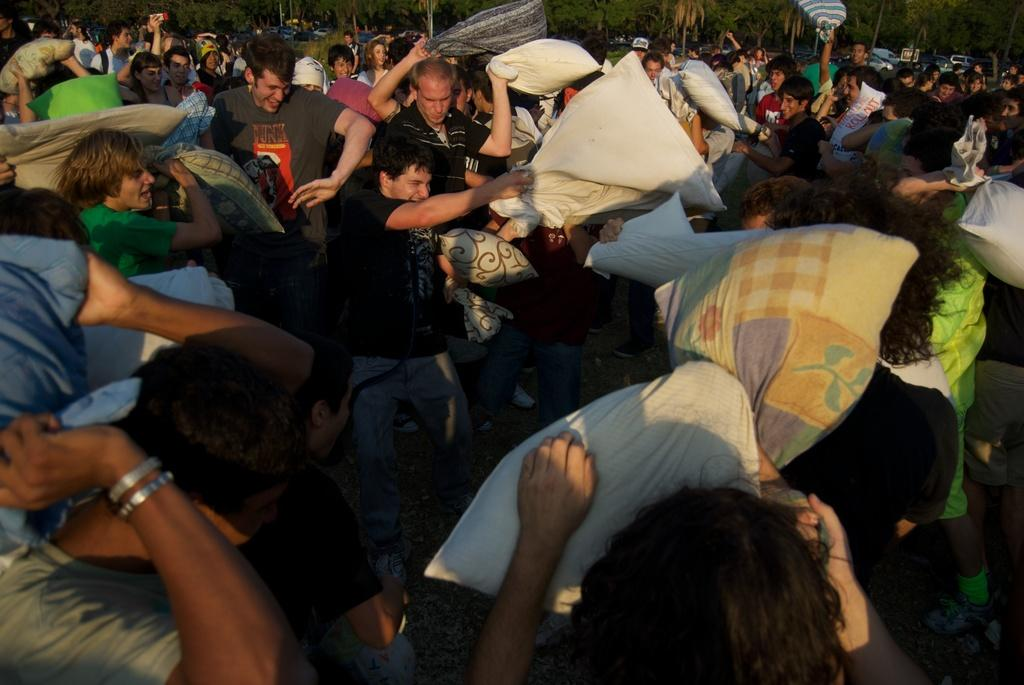How many people are in the image? There are many people in the image. What are the people doing in the image? The people are standing and fighting with each other. What objects are the people holding in their hands? The people are holding pillows in their hands. What can be seen at the top of the image? There are trees visible at the top of the image. What color is the orange that the people are washing in the image? There is no orange or washing activity present in the image. 